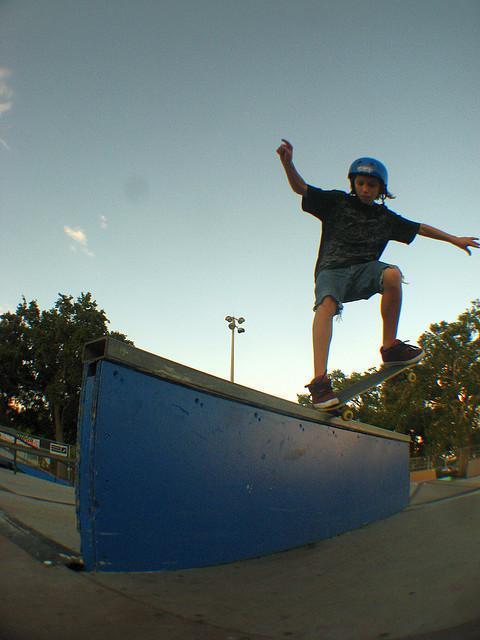How many orange cars are there in the picture?
Give a very brief answer. 0. 